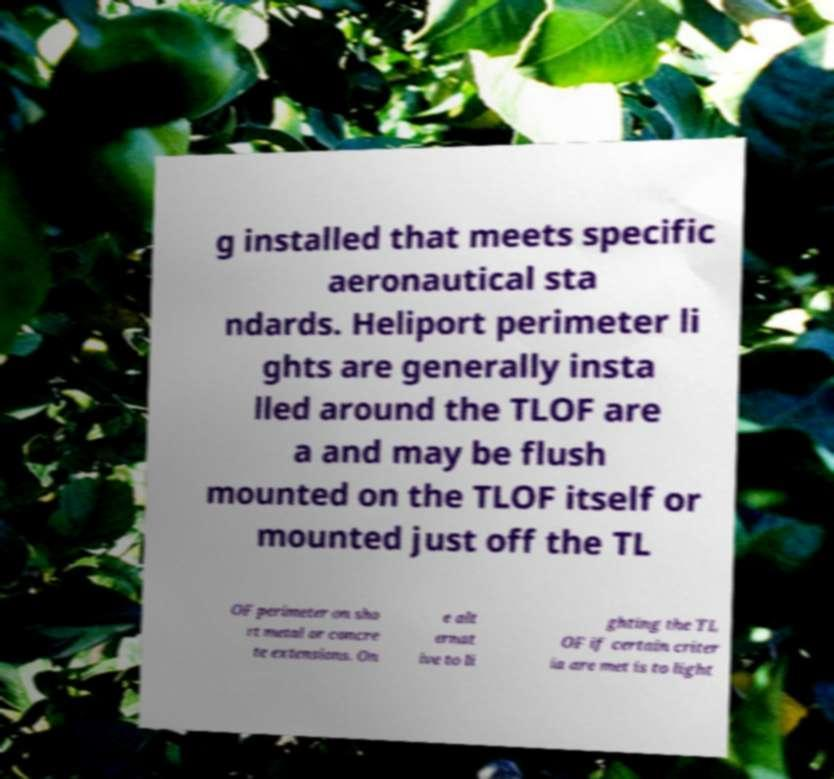For documentation purposes, I need the text within this image transcribed. Could you provide that? g installed that meets specific aeronautical sta ndards. Heliport perimeter li ghts are generally insta lled around the TLOF are a and may be flush mounted on the TLOF itself or mounted just off the TL OF perimeter on sho rt metal or concre te extensions. On e alt ernat ive to li ghting the TL OF if certain criter ia are met is to light 